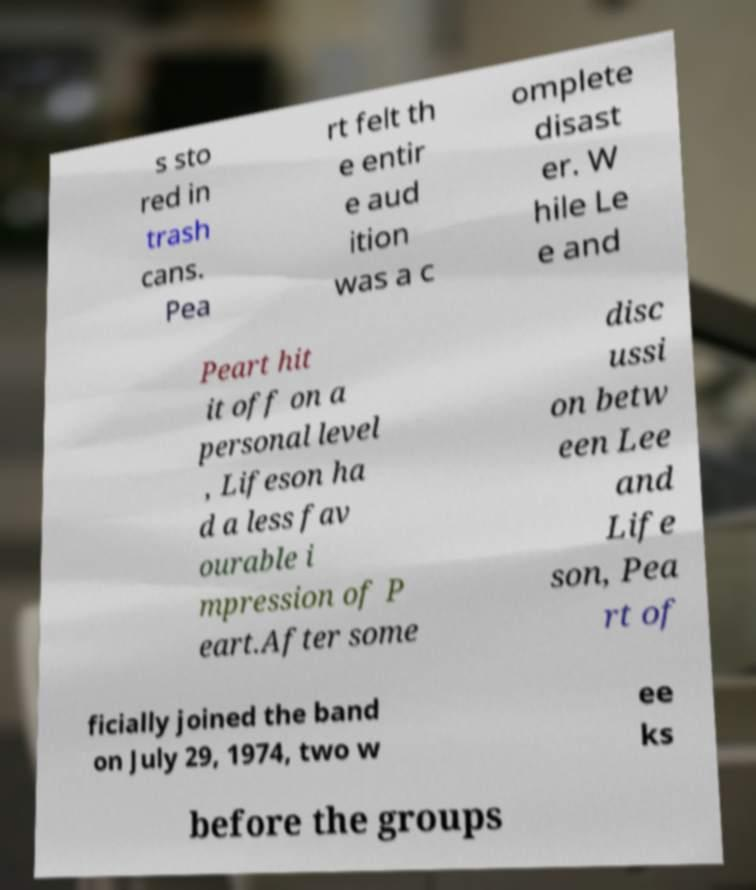Please read and relay the text visible in this image. What does it say? s sto red in trash cans. Pea rt felt th e entir e aud ition was a c omplete disast er. W hile Le e and Peart hit it off on a personal level , Lifeson ha d a less fav ourable i mpression of P eart.After some disc ussi on betw een Lee and Life son, Pea rt of ficially joined the band on July 29, 1974, two w ee ks before the groups 